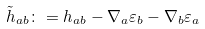Convert formula to latex. <formula><loc_0><loc_0><loc_500><loc_500>\tilde { h } _ { a b } \colon = h _ { a b } - \nabla _ { a } \varepsilon _ { b } - \nabla _ { b } \varepsilon _ { a }</formula> 